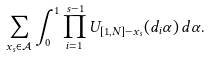Convert formula to latex. <formula><loc_0><loc_0><loc_500><loc_500>\sum _ { x _ { s } \in \mathcal { A } } \int _ { 0 } ^ { 1 } \prod _ { i = 1 } ^ { s - 1 } U _ { [ 1 , N ] - x _ { s } } ( d _ { i } \alpha ) \, d \alpha .</formula> 